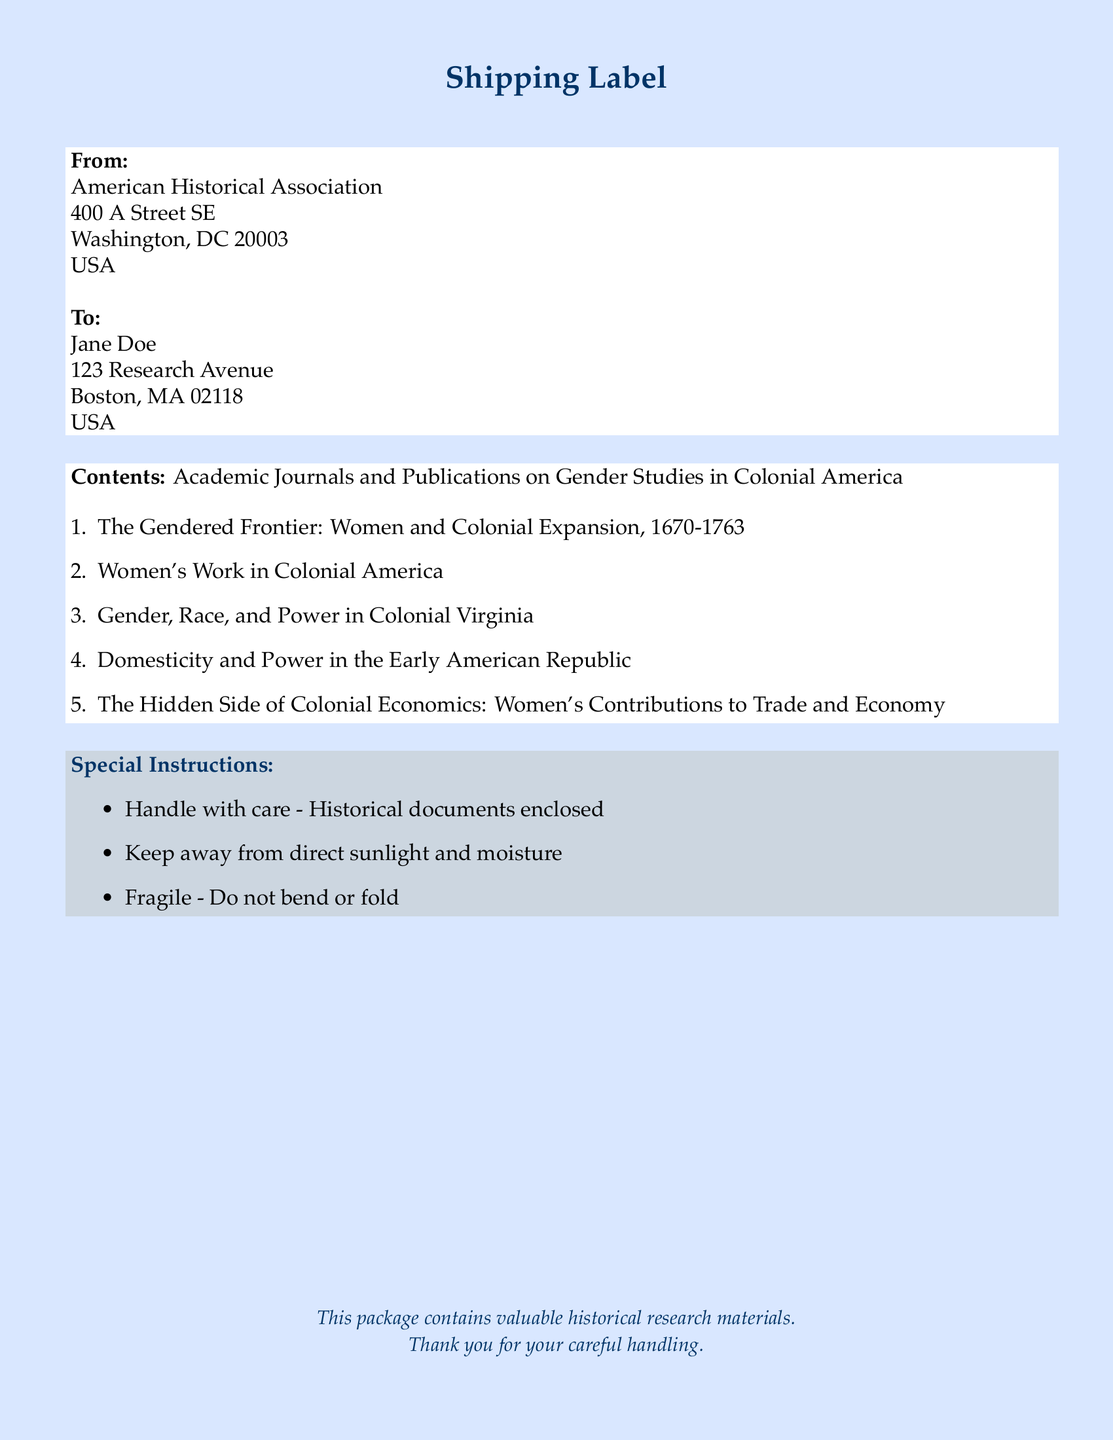What is the name of the sender? The sender is the American Historical Association, which is listed at the top of the document.
Answer: American Historical Association What is the street address of the recipient? The street address is specified under the 'To:' section for Jane Doe.
Answer: 123 Research Avenue How many items are listed in the contents? The total number of items in the contents is counted, which totals five academic journals.
Answer: 5 What is the title of the second item in the list? The second item in the list of contents is noted in the enumeration.
Answer: Women's Work in Colonial America What special instruction is given regarding handling? The document outlines several special handling instructions, including the importance of handling with care.
Answer: Handle with care What type of document is this? The overall format and function of the information contained indicate that this is a shipping label.
Answer: Shipping label What color is used for the page background? The background color is specified at the beginning of the document.
Answer: Light blue What does the final note in the document express? The final note offers a reminder to treat the contents with special consideration due to their value.
Answer: Thank you for your careful handling 